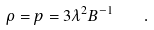Convert formula to latex. <formula><loc_0><loc_0><loc_500><loc_500>\rho = p = 3 \lambda ^ { 2 } B ^ { - 1 } \quad .</formula> 